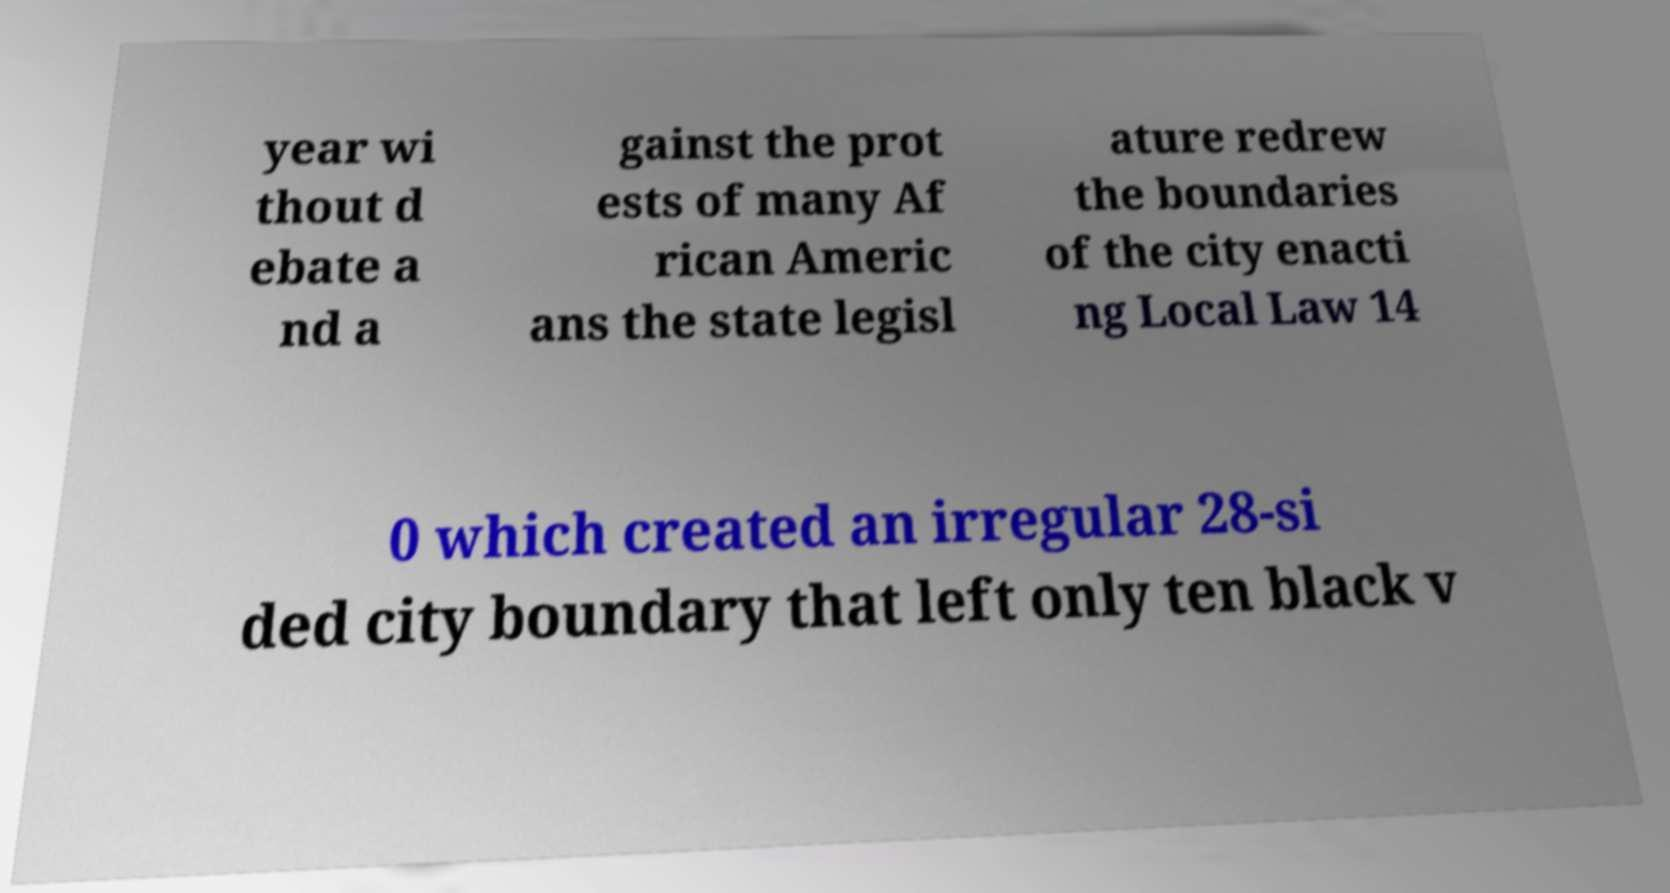I need the written content from this picture converted into text. Can you do that? year wi thout d ebate a nd a gainst the prot ests of many Af rican Americ ans the state legisl ature redrew the boundaries of the city enacti ng Local Law 14 0 which created an irregular 28-si ded city boundary that left only ten black v 